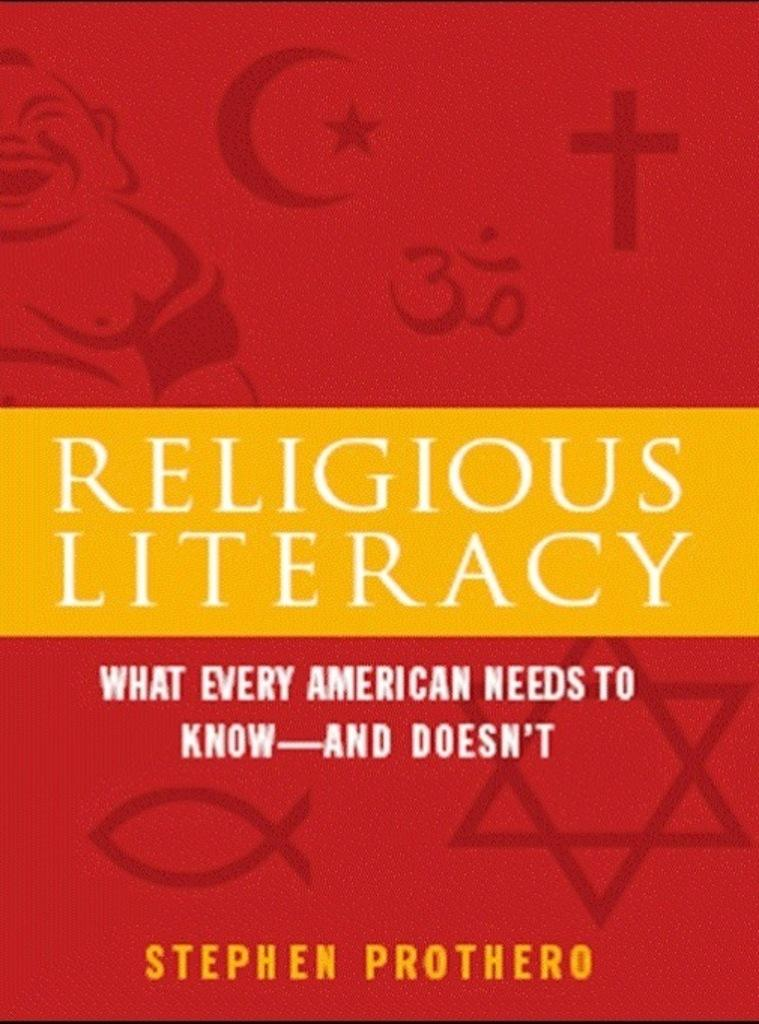<image>
Provide a brief description of the given image. The book called Religious Literacy by Stephen Prothero 